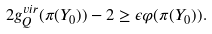Convert formula to latex. <formula><loc_0><loc_0><loc_500><loc_500>2 g _ { Q } ^ { v i r } ( \pi ( Y _ { 0 } ) ) - 2 \geq \epsilon \varphi ( \pi ( Y _ { 0 } ) ) .</formula> 